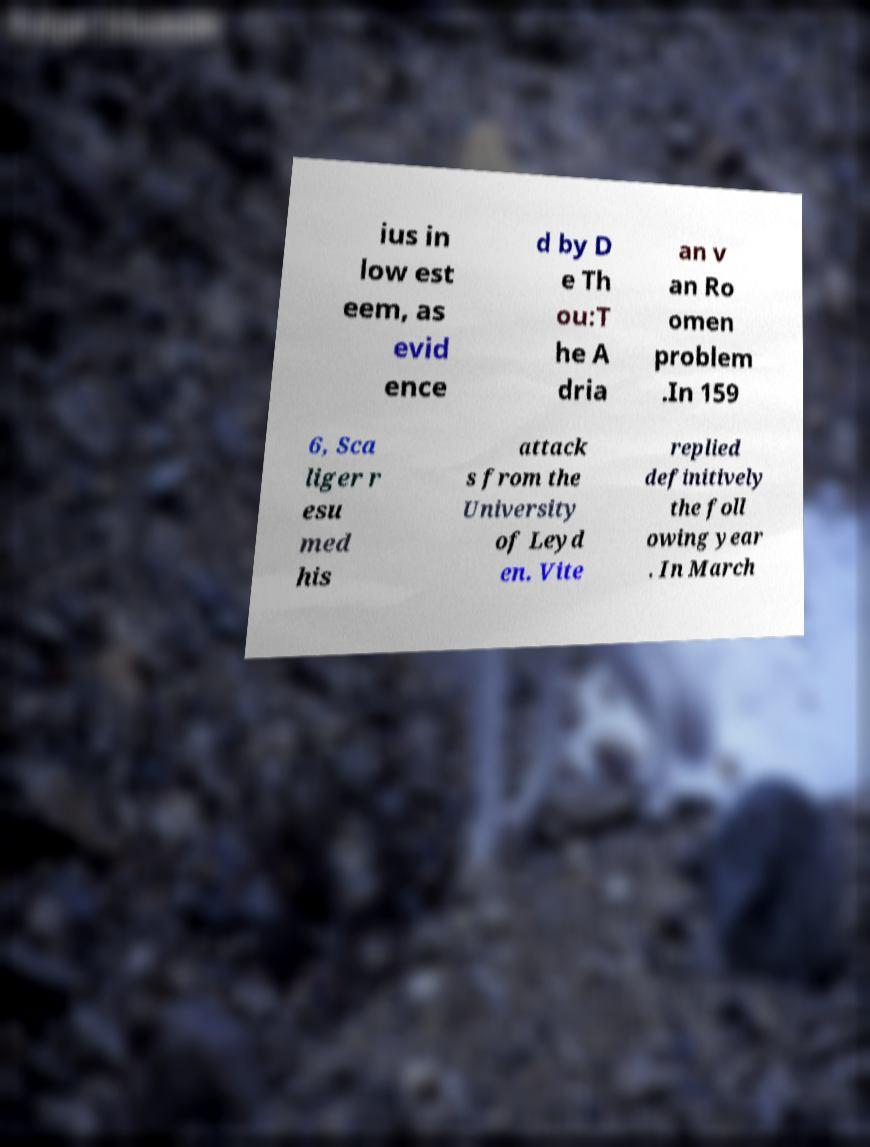Please read and relay the text visible in this image. What does it say? ius in low est eem, as evid ence d by D e Th ou:T he A dria an v an Ro omen problem .In 159 6, Sca liger r esu med his attack s from the University of Leyd en. Vite replied definitively the foll owing year . In March 